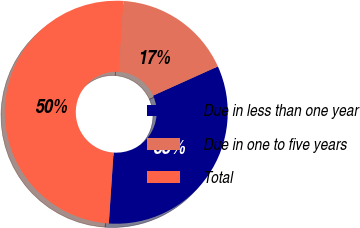Convert chart to OTSL. <chart><loc_0><loc_0><loc_500><loc_500><pie_chart><fcel>Due in less than one year<fcel>Due in one to five years<fcel>Total<nl><fcel>32.8%<fcel>17.2%<fcel>50.0%<nl></chart> 